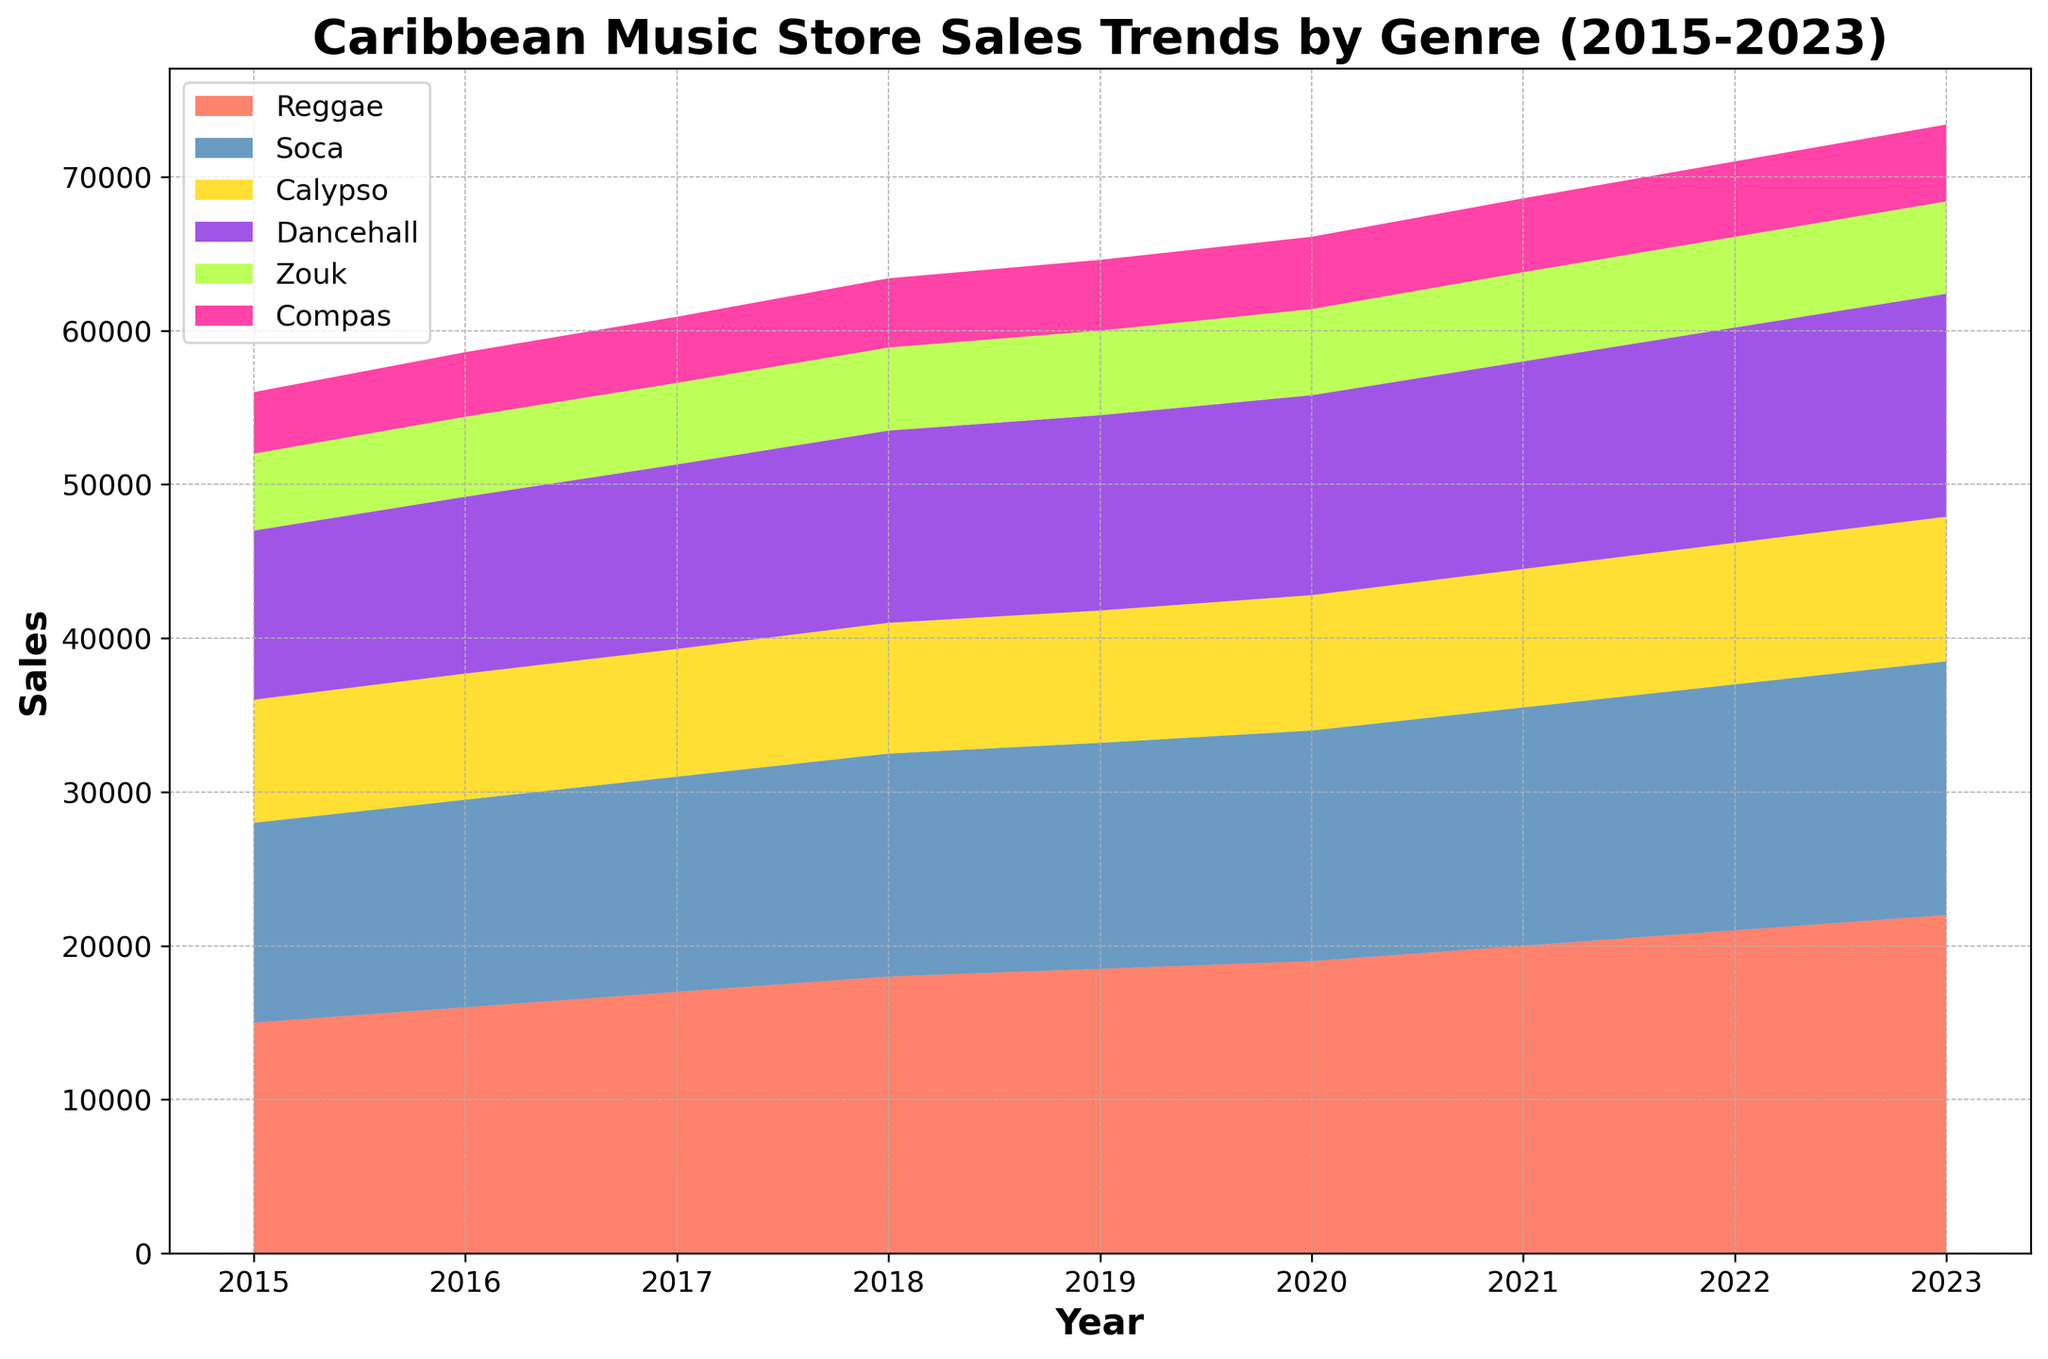Which genre had the highest sales in 2023? To determine the genre with the highest sales in 2023, look at the sales values for each genre in that year. From the chart, Reggae has the highest sales.
Answer: Reggae Which genre showed the most consistent increase in sales over the years? Track the sales trend of each genre over the years from 2015 to 2023. The genre that consistently increases without any decline is Reggae.
Answer: Reggae How did the sales of Dancehall compare to Zouk in 2020? Look at the sales figures for Dancehall and Zouk in 2020. Dancehall had a sales value of 13,000 while Zouk had a sales value of 5,600.
Answer: Dancehall had higher sales What was the combined sales of Soca and Calypso in 2019? Add the sales values of Soca and Calypso in 2019. Soca had 14,700 and Calypso had 8,600. So, 14,700 + 8,600 = 23,300.
Answer: 23,300 Which genre had the least increase in sales from 2015 to 2023? Determine the sales increase by subtracting the 2015 sales value from the 2023 sales value for each genre. The smallest difference is for Compas: 5,000 - 4,000 = 1,000.
Answer: Compas Between which two years did Soca see the highest jump in sales? Calculate the year-on-year increase for Soca and find the maximum increase. The increase from 2022 to 2023 was the highest, from 16,000 to 16,500, i.e., 500.
Answer: 2022 to 2023 In which year did Reggae sales surpass 20,000? Identify the year in which the Reggae sales value first exceeded 20,000. This occurred in 2021.
Answer: 2021 How do the 2015 sales of Reggae compare to the 2023 sales of Compas? Compare the 2015 sales value of Reggae, which is 15,000, to the 2023 sales value of Compas, which is 5,000. Reggae sales in 2015 were significantly higher.
Answer: Reggae sales were higher Which genre had a sales value closest to 10,000 in any year? Find the sales value nearest to 10,000 across all years and genres. Dancehall's sales in 2015, which were 11,000, is the closest.
Answer: Dancehall in 2015 